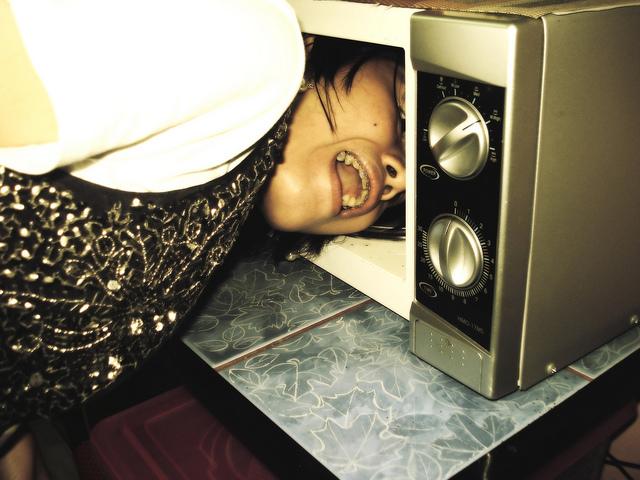What is this person sticking in the microwave?
Give a very brief answer. Head. Is the microwave on?
Answer briefly. No. How many eyes are in the photo?
Concise answer only. 1. What color is the microwave?
Give a very brief answer. Silver. 